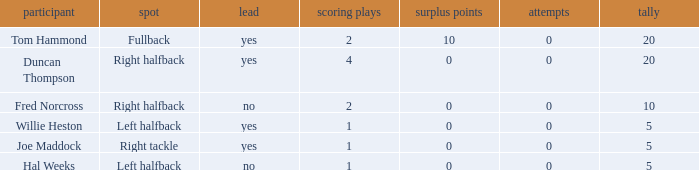What is the highest field goals when there were more than 1 touchdown and 0 extra points? 0.0. 